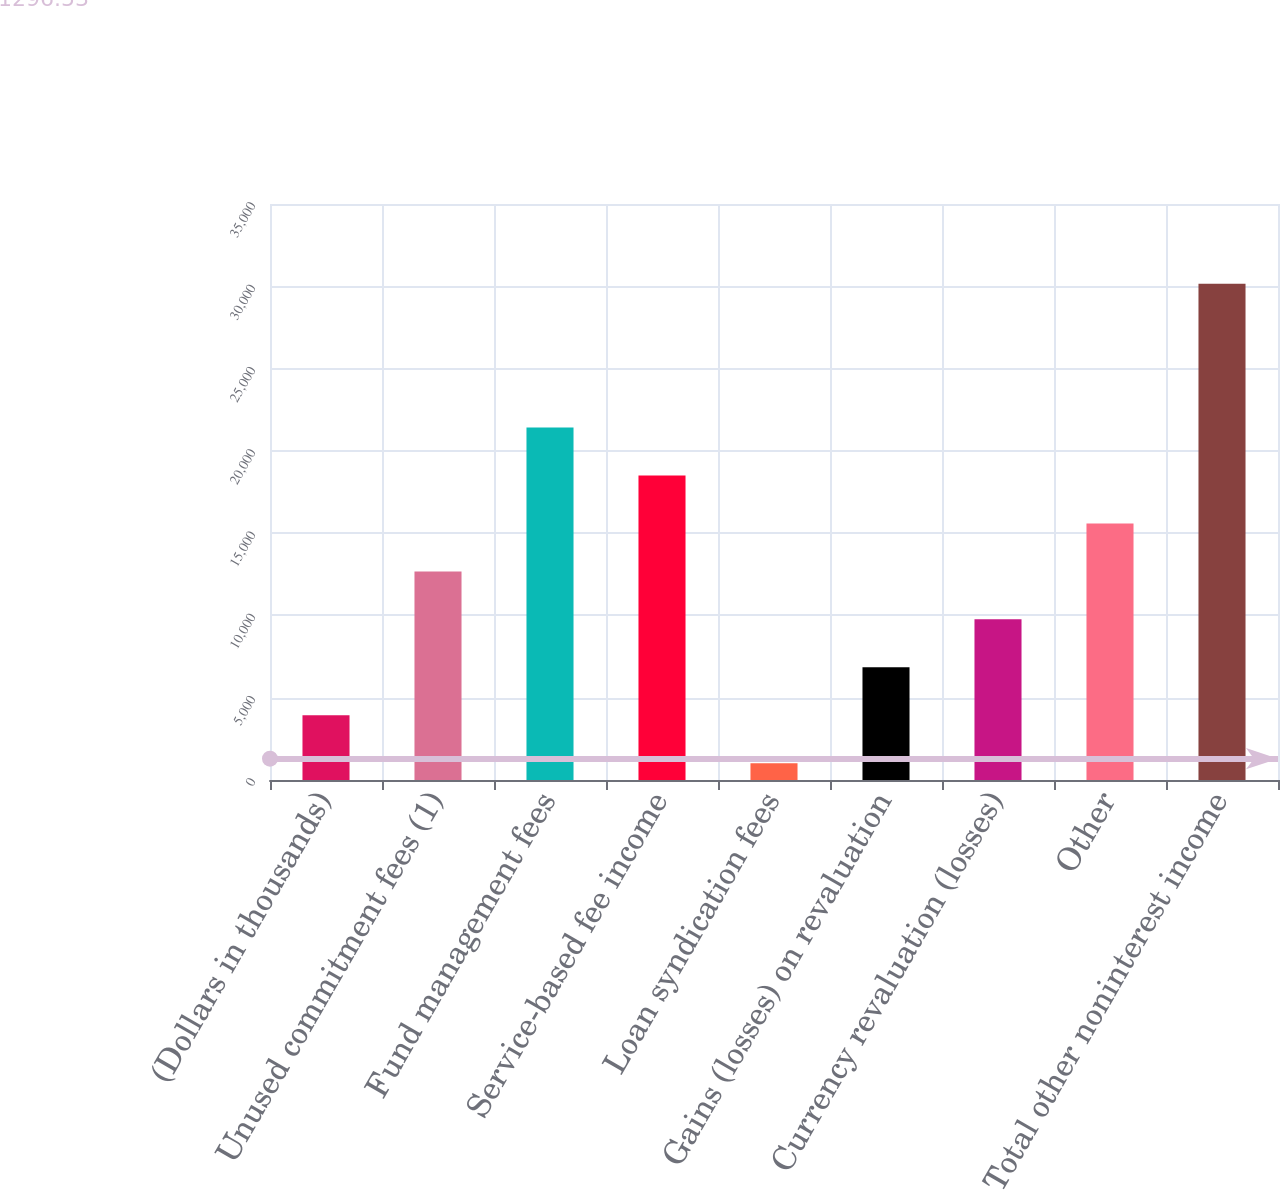<chart> <loc_0><loc_0><loc_500><loc_500><bar_chart><fcel>(Dollars in thousands)<fcel>Unused commitment fees (1)<fcel>Fund management fees<fcel>Service-based fee income<fcel>Loan syndication fees<fcel>Gains (losses) on revaluation<fcel>Currency revaluation (losses)<fcel>Other<fcel>Total other noninterest income<nl><fcel>3933.5<fcel>12674<fcel>21414.5<fcel>18501<fcel>1020<fcel>6847<fcel>9760.5<fcel>15587.5<fcel>30155<nl></chart> 